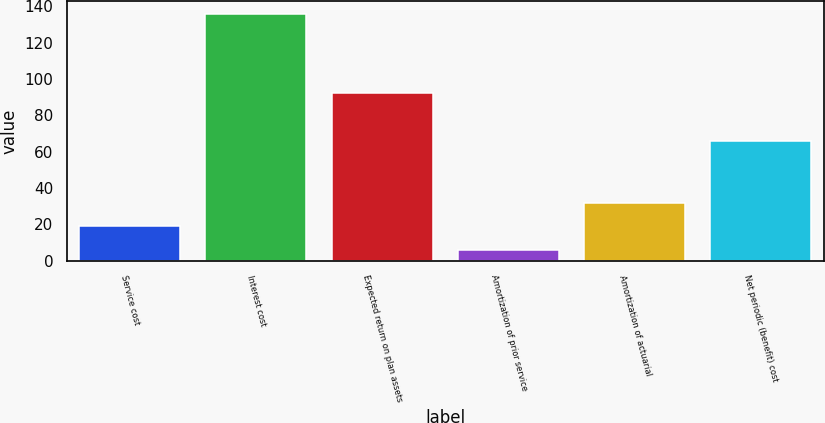Convert chart to OTSL. <chart><loc_0><loc_0><loc_500><loc_500><bar_chart><fcel>Service cost<fcel>Interest cost<fcel>Expected return on plan assets<fcel>Amortization of prior service<fcel>Amortization of actuarial<fcel>Net periodic (benefit) cost<nl><fcel>19<fcel>136<fcel>92<fcel>6<fcel>32<fcel>66<nl></chart> 